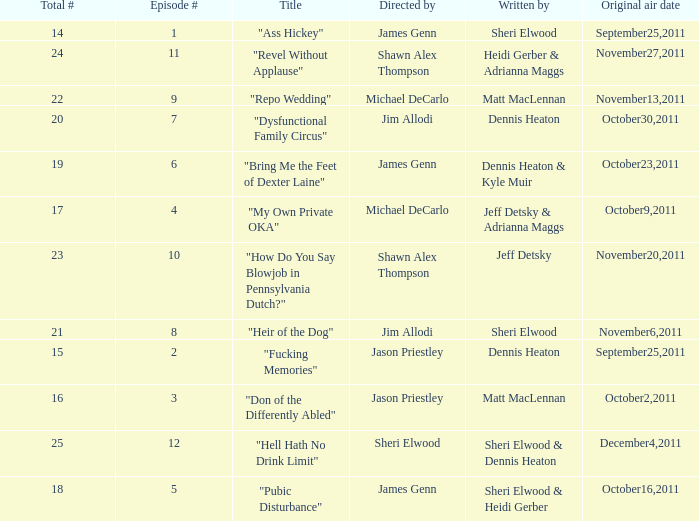How many different episode numbers are there for the episodes directed by Sheri Elwood? 1.0. 